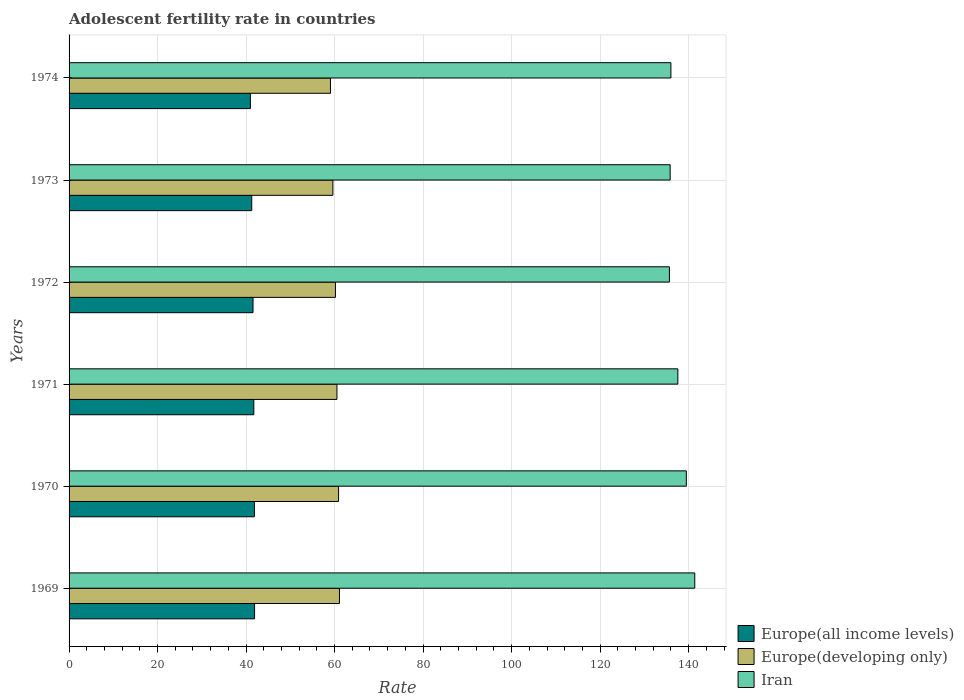Are the number of bars per tick equal to the number of legend labels?
Offer a terse response. Yes. How many bars are there on the 4th tick from the top?
Keep it short and to the point. 3. How many bars are there on the 4th tick from the bottom?
Make the answer very short. 3. What is the label of the 3rd group of bars from the top?
Your response must be concise. 1972. In how many cases, is the number of bars for a given year not equal to the number of legend labels?
Your answer should be very brief. 0. What is the adolescent fertility rate in Europe(all income levels) in 1973?
Give a very brief answer. 41.28. Across all years, what is the maximum adolescent fertility rate in Europe(developing only)?
Provide a succinct answer. 61.1. Across all years, what is the minimum adolescent fertility rate in Iran?
Your answer should be very brief. 135.66. In which year was the adolescent fertility rate in Iran maximum?
Ensure brevity in your answer.  1969. In which year was the adolescent fertility rate in Europe(developing only) minimum?
Offer a very short reply. 1974. What is the total adolescent fertility rate in Europe(all income levels) in the graph?
Ensure brevity in your answer.  249.37. What is the difference between the adolescent fertility rate in Europe(all income levels) in 1972 and that in 1973?
Your answer should be compact. 0.29. What is the difference between the adolescent fertility rate in Europe(all income levels) in 1969 and the adolescent fertility rate in Europe(developing only) in 1974?
Give a very brief answer. -17.15. What is the average adolescent fertility rate in Europe(all income levels) per year?
Your response must be concise. 41.56. In the year 1974, what is the difference between the adolescent fertility rate in Iran and adolescent fertility rate in Europe(all income levels)?
Your response must be concise. 95.03. What is the ratio of the adolescent fertility rate in Iran in 1969 to that in 1970?
Make the answer very short. 1.01. What is the difference between the highest and the second highest adolescent fertility rate in Europe(developing only)?
Keep it short and to the point. 0.2. What is the difference between the highest and the lowest adolescent fertility rate in Europe(all income levels)?
Keep it short and to the point. 0.94. What does the 2nd bar from the top in 1971 represents?
Keep it short and to the point. Europe(developing only). What does the 1st bar from the bottom in 1971 represents?
Provide a short and direct response. Europe(all income levels). Are the values on the major ticks of X-axis written in scientific E-notation?
Ensure brevity in your answer.  No. Does the graph contain grids?
Keep it short and to the point. Yes. What is the title of the graph?
Keep it short and to the point. Adolescent fertility rate in countries. Does "Kosovo" appear as one of the legend labels in the graph?
Provide a succinct answer. No. What is the label or title of the X-axis?
Provide a succinct answer. Rate. What is the Rate of Europe(all income levels) in 1969?
Your response must be concise. 41.92. What is the Rate of Europe(developing only) in 1969?
Offer a very short reply. 61.1. What is the Rate of Iran in 1969?
Offer a very short reply. 141.39. What is the Rate of Europe(all income levels) in 1970?
Make the answer very short. 41.88. What is the Rate of Europe(developing only) in 1970?
Your answer should be compact. 60.9. What is the Rate in Iran in 1970?
Provide a succinct answer. 139.48. What is the Rate in Europe(all income levels) in 1971?
Your answer should be very brief. 41.75. What is the Rate in Europe(developing only) in 1971?
Your response must be concise. 60.54. What is the Rate of Iran in 1971?
Provide a succinct answer. 137.57. What is the Rate of Europe(all income levels) in 1972?
Offer a very short reply. 41.57. What is the Rate of Europe(developing only) in 1972?
Offer a terse response. 60.2. What is the Rate of Iran in 1972?
Give a very brief answer. 135.66. What is the Rate in Europe(all income levels) in 1973?
Keep it short and to the point. 41.28. What is the Rate of Europe(developing only) in 1973?
Make the answer very short. 59.62. What is the Rate in Iran in 1973?
Give a very brief answer. 135.83. What is the Rate in Europe(all income levels) in 1974?
Your answer should be compact. 40.97. What is the Rate of Europe(developing only) in 1974?
Your answer should be very brief. 59.07. What is the Rate in Iran in 1974?
Ensure brevity in your answer.  136. Across all years, what is the maximum Rate in Europe(all income levels)?
Your response must be concise. 41.92. Across all years, what is the maximum Rate of Europe(developing only)?
Keep it short and to the point. 61.1. Across all years, what is the maximum Rate of Iran?
Provide a succinct answer. 141.39. Across all years, what is the minimum Rate in Europe(all income levels)?
Provide a succinct answer. 40.97. Across all years, what is the minimum Rate of Europe(developing only)?
Your answer should be very brief. 59.07. Across all years, what is the minimum Rate of Iran?
Provide a succinct answer. 135.66. What is the total Rate in Europe(all income levels) in the graph?
Provide a short and direct response. 249.37. What is the total Rate in Europe(developing only) in the graph?
Your response must be concise. 361.42. What is the total Rate of Iran in the graph?
Your answer should be very brief. 825.94. What is the difference between the Rate in Europe(all income levels) in 1969 and that in 1970?
Give a very brief answer. 0.04. What is the difference between the Rate in Europe(developing only) in 1969 and that in 1970?
Your response must be concise. 0.2. What is the difference between the Rate in Iran in 1969 and that in 1970?
Keep it short and to the point. 1.91. What is the difference between the Rate of Europe(all income levels) in 1969 and that in 1971?
Provide a succinct answer. 0.17. What is the difference between the Rate in Europe(developing only) in 1969 and that in 1971?
Provide a short and direct response. 0.56. What is the difference between the Rate in Iran in 1969 and that in 1971?
Keep it short and to the point. 3.82. What is the difference between the Rate of Europe(all income levels) in 1969 and that in 1972?
Provide a short and direct response. 0.35. What is the difference between the Rate of Europe(developing only) in 1969 and that in 1972?
Your answer should be compact. 0.9. What is the difference between the Rate of Iran in 1969 and that in 1972?
Provide a short and direct response. 5.73. What is the difference between the Rate in Europe(all income levels) in 1969 and that in 1973?
Offer a terse response. 0.64. What is the difference between the Rate in Europe(developing only) in 1969 and that in 1973?
Your response must be concise. 1.48. What is the difference between the Rate in Iran in 1969 and that in 1973?
Offer a terse response. 5.56. What is the difference between the Rate in Europe(all income levels) in 1969 and that in 1974?
Offer a very short reply. 0.94. What is the difference between the Rate of Europe(developing only) in 1969 and that in 1974?
Provide a succinct answer. 2.03. What is the difference between the Rate of Iran in 1969 and that in 1974?
Your response must be concise. 5.39. What is the difference between the Rate in Europe(all income levels) in 1970 and that in 1971?
Provide a succinct answer. 0.13. What is the difference between the Rate in Europe(developing only) in 1970 and that in 1971?
Your response must be concise. 0.36. What is the difference between the Rate in Iran in 1970 and that in 1971?
Offer a terse response. 1.91. What is the difference between the Rate in Europe(all income levels) in 1970 and that in 1972?
Provide a short and direct response. 0.31. What is the difference between the Rate in Europe(developing only) in 1970 and that in 1972?
Give a very brief answer. 0.7. What is the difference between the Rate of Iran in 1970 and that in 1972?
Your answer should be compact. 3.82. What is the difference between the Rate of Europe(all income levels) in 1970 and that in 1973?
Offer a terse response. 0.6. What is the difference between the Rate of Europe(developing only) in 1970 and that in 1973?
Your response must be concise. 1.28. What is the difference between the Rate of Iran in 1970 and that in 1973?
Offer a terse response. 3.65. What is the difference between the Rate in Europe(all income levels) in 1970 and that in 1974?
Give a very brief answer. 0.91. What is the difference between the Rate of Europe(developing only) in 1970 and that in 1974?
Your answer should be compact. 1.83. What is the difference between the Rate in Iran in 1970 and that in 1974?
Provide a short and direct response. 3.48. What is the difference between the Rate in Europe(all income levels) in 1971 and that in 1972?
Provide a succinct answer. 0.18. What is the difference between the Rate in Europe(developing only) in 1971 and that in 1972?
Offer a very short reply. 0.34. What is the difference between the Rate in Iran in 1971 and that in 1972?
Offer a very short reply. 1.91. What is the difference between the Rate of Europe(all income levels) in 1971 and that in 1973?
Ensure brevity in your answer.  0.47. What is the difference between the Rate in Europe(developing only) in 1971 and that in 1973?
Provide a succinct answer. 0.92. What is the difference between the Rate in Iran in 1971 and that in 1973?
Provide a short and direct response. 1.74. What is the difference between the Rate of Europe(all income levels) in 1971 and that in 1974?
Offer a very short reply. 0.78. What is the difference between the Rate in Europe(developing only) in 1971 and that in 1974?
Keep it short and to the point. 1.47. What is the difference between the Rate of Iran in 1971 and that in 1974?
Your response must be concise. 1.57. What is the difference between the Rate in Europe(all income levels) in 1972 and that in 1973?
Provide a succinct answer. 0.29. What is the difference between the Rate in Europe(developing only) in 1972 and that in 1973?
Your answer should be compact. 0.58. What is the difference between the Rate of Iran in 1972 and that in 1973?
Keep it short and to the point. -0.17. What is the difference between the Rate in Europe(all income levels) in 1972 and that in 1974?
Your answer should be very brief. 0.6. What is the difference between the Rate of Europe(developing only) in 1972 and that in 1974?
Offer a terse response. 1.13. What is the difference between the Rate of Iran in 1972 and that in 1974?
Keep it short and to the point. -0.34. What is the difference between the Rate in Europe(all income levels) in 1973 and that in 1974?
Provide a succinct answer. 0.31. What is the difference between the Rate in Europe(developing only) in 1973 and that in 1974?
Provide a succinct answer. 0.55. What is the difference between the Rate of Iran in 1973 and that in 1974?
Provide a short and direct response. -0.17. What is the difference between the Rate of Europe(all income levels) in 1969 and the Rate of Europe(developing only) in 1970?
Your answer should be compact. -18.98. What is the difference between the Rate in Europe(all income levels) in 1969 and the Rate in Iran in 1970?
Offer a terse response. -97.56. What is the difference between the Rate in Europe(developing only) in 1969 and the Rate in Iran in 1970?
Your answer should be compact. -78.38. What is the difference between the Rate in Europe(all income levels) in 1969 and the Rate in Europe(developing only) in 1971?
Provide a succinct answer. -18.62. What is the difference between the Rate of Europe(all income levels) in 1969 and the Rate of Iran in 1971?
Provide a succinct answer. -95.65. What is the difference between the Rate in Europe(developing only) in 1969 and the Rate in Iran in 1971?
Offer a terse response. -76.47. What is the difference between the Rate of Europe(all income levels) in 1969 and the Rate of Europe(developing only) in 1972?
Give a very brief answer. -18.28. What is the difference between the Rate of Europe(all income levels) in 1969 and the Rate of Iran in 1972?
Offer a very short reply. -93.74. What is the difference between the Rate in Europe(developing only) in 1969 and the Rate in Iran in 1972?
Offer a very short reply. -74.56. What is the difference between the Rate in Europe(all income levels) in 1969 and the Rate in Europe(developing only) in 1973?
Your response must be concise. -17.7. What is the difference between the Rate of Europe(all income levels) in 1969 and the Rate of Iran in 1973?
Your answer should be very brief. -93.91. What is the difference between the Rate in Europe(developing only) in 1969 and the Rate in Iran in 1973?
Offer a terse response. -74.73. What is the difference between the Rate of Europe(all income levels) in 1969 and the Rate of Europe(developing only) in 1974?
Give a very brief answer. -17.15. What is the difference between the Rate of Europe(all income levels) in 1969 and the Rate of Iran in 1974?
Your answer should be very brief. -94.08. What is the difference between the Rate in Europe(developing only) in 1969 and the Rate in Iran in 1974?
Provide a succinct answer. -74.9. What is the difference between the Rate of Europe(all income levels) in 1970 and the Rate of Europe(developing only) in 1971?
Offer a very short reply. -18.66. What is the difference between the Rate in Europe(all income levels) in 1970 and the Rate in Iran in 1971?
Keep it short and to the point. -95.69. What is the difference between the Rate of Europe(developing only) in 1970 and the Rate of Iran in 1971?
Your answer should be compact. -76.67. What is the difference between the Rate of Europe(all income levels) in 1970 and the Rate of Europe(developing only) in 1972?
Give a very brief answer. -18.31. What is the difference between the Rate of Europe(all income levels) in 1970 and the Rate of Iran in 1972?
Provide a succinct answer. -93.78. What is the difference between the Rate in Europe(developing only) in 1970 and the Rate in Iran in 1972?
Your response must be concise. -74.76. What is the difference between the Rate of Europe(all income levels) in 1970 and the Rate of Europe(developing only) in 1973?
Give a very brief answer. -17.74. What is the difference between the Rate in Europe(all income levels) in 1970 and the Rate in Iran in 1973?
Keep it short and to the point. -93.95. What is the difference between the Rate in Europe(developing only) in 1970 and the Rate in Iran in 1973?
Offer a terse response. -74.93. What is the difference between the Rate of Europe(all income levels) in 1970 and the Rate of Europe(developing only) in 1974?
Give a very brief answer. -17.19. What is the difference between the Rate of Europe(all income levels) in 1970 and the Rate of Iran in 1974?
Give a very brief answer. -94.12. What is the difference between the Rate in Europe(developing only) in 1970 and the Rate in Iran in 1974?
Your answer should be compact. -75.1. What is the difference between the Rate of Europe(all income levels) in 1971 and the Rate of Europe(developing only) in 1972?
Provide a short and direct response. -18.45. What is the difference between the Rate in Europe(all income levels) in 1971 and the Rate in Iran in 1972?
Offer a terse response. -93.91. What is the difference between the Rate of Europe(developing only) in 1971 and the Rate of Iran in 1972?
Provide a short and direct response. -75.12. What is the difference between the Rate in Europe(all income levels) in 1971 and the Rate in Europe(developing only) in 1973?
Offer a very short reply. -17.87. What is the difference between the Rate in Europe(all income levels) in 1971 and the Rate in Iran in 1973?
Make the answer very short. -94.08. What is the difference between the Rate of Europe(developing only) in 1971 and the Rate of Iran in 1973?
Make the answer very short. -75.29. What is the difference between the Rate of Europe(all income levels) in 1971 and the Rate of Europe(developing only) in 1974?
Your answer should be compact. -17.32. What is the difference between the Rate in Europe(all income levels) in 1971 and the Rate in Iran in 1974?
Ensure brevity in your answer.  -94.25. What is the difference between the Rate in Europe(developing only) in 1971 and the Rate in Iran in 1974?
Your response must be concise. -75.46. What is the difference between the Rate of Europe(all income levels) in 1972 and the Rate of Europe(developing only) in 1973?
Ensure brevity in your answer.  -18.05. What is the difference between the Rate in Europe(all income levels) in 1972 and the Rate in Iran in 1973?
Your answer should be compact. -94.26. What is the difference between the Rate in Europe(developing only) in 1972 and the Rate in Iran in 1973?
Provide a short and direct response. -75.63. What is the difference between the Rate of Europe(all income levels) in 1972 and the Rate of Europe(developing only) in 1974?
Make the answer very short. -17.5. What is the difference between the Rate in Europe(all income levels) in 1972 and the Rate in Iran in 1974?
Your answer should be very brief. -94.43. What is the difference between the Rate in Europe(developing only) in 1972 and the Rate in Iran in 1974?
Ensure brevity in your answer.  -75.81. What is the difference between the Rate in Europe(all income levels) in 1973 and the Rate in Europe(developing only) in 1974?
Make the answer very short. -17.79. What is the difference between the Rate of Europe(all income levels) in 1973 and the Rate of Iran in 1974?
Provide a succinct answer. -94.72. What is the difference between the Rate of Europe(developing only) in 1973 and the Rate of Iran in 1974?
Offer a terse response. -76.38. What is the average Rate in Europe(all income levels) per year?
Keep it short and to the point. 41.56. What is the average Rate in Europe(developing only) per year?
Your answer should be compact. 60.24. What is the average Rate in Iran per year?
Keep it short and to the point. 137.66. In the year 1969, what is the difference between the Rate in Europe(all income levels) and Rate in Europe(developing only)?
Offer a terse response. -19.18. In the year 1969, what is the difference between the Rate in Europe(all income levels) and Rate in Iran?
Offer a terse response. -99.48. In the year 1969, what is the difference between the Rate of Europe(developing only) and Rate of Iran?
Make the answer very short. -80.29. In the year 1970, what is the difference between the Rate in Europe(all income levels) and Rate in Europe(developing only)?
Give a very brief answer. -19.02. In the year 1970, what is the difference between the Rate in Europe(all income levels) and Rate in Iran?
Your answer should be very brief. -97.6. In the year 1970, what is the difference between the Rate of Europe(developing only) and Rate of Iran?
Your answer should be compact. -78.58. In the year 1971, what is the difference between the Rate in Europe(all income levels) and Rate in Europe(developing only)?
Provide a succinct answer. -18.79. In the year 1971, what is the difference between the Rate in Europe(all income levels) and Rate in Iran?
Your response must be concise. -95.82. In the year 1971, what is the difference between the Rate in Europe(developing only) and Rate in Iran?
Keep it short and to the point. -77.03. In the year 1972, what is the difference between the Rate of Europe(all income levels) and Rate of Europe(developing only)?
Provide a short and direct response. -18.63. In the year 1972, what is the difference between the Rate in Europe(all income levels) and Rate in Iran?
Your answer should be compact. -94.09. In the year 1972, what is the difference between the Rate in Europe(developing only) and Rate in Iran?
Give a very brief answer. -75.46. In the year 1973, what is the difference between the Rate in Europe(all income levels) and Rate in Europe(developing only)?
Offer a very short reply. -18.34. In the year 1973, what is the difference between the Rate in Europe(all income levels) and Rate in Iran?
Offer a terse response. -94.55. In the year 1973, what is the difference between the Rate in Europe(developing only) and Rate in Iran?
Ensure brevity in your answer.  -76.21. In the year 1974, what is the difference between the Rate of Europe(all income levels) and Rate of Europe(developing only)?
Provide a succinct answer. -18.09. In the year 1974, what is the difference between the Rate of Europe(all income levels) and Rate of Iran?
Offer a very short reply. -95.03. In the year 1974, what is the difference between the Rate of Europe(developing only) and Rate of Iran?
Offer a terse response. -76.93. What is the ratio of the Rate of Europe(developing only) in 1969 to that in 1970?
Your answer should be very brief. 1. What is the ratio of the Rate of Iran in 1969 to that in 1970?
Ensure brevity in your answer.  1.01. What is the ratio of the Rate in Europe(developing only) in 1969 to that in 1971?
Provide a short and direct response. 1.01. What is the ratio of the Rate in Iran in 1969 to that in 1971?
Your answer should be compact. 1.03. What is the ratio of the Rate of Europe(all income levels) in 1969 to that in 1972?
Give a very brief answer. 1.01. What is the ratio of the Rate of Europe(developing only) in 1969 to that in 1972?
Your answer should be very brief. 1.01. What is the ratio of the Rate in Iran in 1969 to that in 1972?
Offer a very short reply. 1.04. What is the ratio of the Rate of Europe(all income levels) in 1969 to that in 1973?
Make the answer very short. 1.02. What is the ratio of the Rate of Europe(developing only) in 1969 to that in 1973?
Provide a short and direct response. 1.02. What is the ratio of the Rate in Iran in 1969 to that in 1973?
Your answer should be compact. 1.04. What is the ratio of the Rate in Europe(all income levels) in 1969 to that in 1974?
Provide a succinct answer. 1.02. What is the ratio of the Rate in Europe(developing only) in 1969 to that in 1974?
Offer a very short reply. 1.03. What is the ratio of the Rate of Iran in 1969 to that in 1974?
Keep it short and to the point. 1.04. What is the ratio of the Rate of Europe(all income levels) in 1970 to that in 1971?
Provide a succinct answer. 1. What is the ratio of the Rate in Europe(developing only) in 1970 to that in 1971?
Your response must be concise. 1.01. What is the ratio of the Rate of Iran in 1970 to that in 1971?
Provide a succinct answer. 1.01. What is the ratio of the Rate of Europe(all income levels) in 1970 to that in 1972?
Provide a short and direct response. 1.01. What is the ratio of the Rate in Europe(developing only) in 1970 to that in 1972?
Provide a succinct answer. 1.01. What is the ratio of the Rate in Iran in 1970 to that in 1972?
Keep it short and to the point. 1.03. What is the ratio of the Rate of Europe(all income levels) in 1970 to that in 1973?
Give a very brief answer. 1.01. What is the ratio of the Rate in Europe(developing only) in 1970 to that in 1973?
Offer a terse response. 1.02. What is the ratio of the Rate in Iran in 1970 to that in 1973?
Provide a succinct answer. 1.03. What is the ratio of the Rate in Europe(all income levels) in 1970 to that in 1974?
Your answer should be compact. 1.02. What is the ratio of the Rate of Europe(developing only) in 1970 to that in 1974?
Provide a short and direct response. 1.03. What is the ratio of the Rate in Iran in 1970 to that in 1974?
Give a very brief answer. 1.03. What is the ratio of the Rate of Europe(developing only) in 1971 to that in 1972?
Your answer should be compact. 1.01. What is the ratio of the Rate in Iran in 1971 to that in 1972?
Keep it short and to the point. 1.01. What is the ratio of the Rate in Europe(all income levels) in 1971 to that in 1973?
Offer a very short reply. 1.01. What is the ratio of the Rate in Europe(developing only) in 1971 to that in 1973?
Your answer should be very brief. 1.02. What is the ratio of the Rate in Iran in 1971 to that in 1973?
Give a very brief answer. 1.01. What is the ratio of the Rate in Europe(all income levels) in 1971 to that in 1974?
Your answer should be compact. 1.02. What is the ratio of the Rate in Europe(developing only) in 1971 to that in 1974?
Your answer should be compact. 1.02. What is the ratio of the Rate in Iran in 1971 to that in 1974?
Your answer should be compact. 1.01. What is the ratio of the Rate of Europe(all income levels) in 1972 to that in 1973?
Keep it short and to the point. 1.01. What is the ratio of the Rate in Europe(developing only) in 1972 to that in 1973?
Offer a terse response. 1.01. What is the ratio of the Rate of Iran in 1972 to that in 1973?
Provide a short and direct response. 1. What is the ratio of the Rate in Europe(all income levels) in 1972 to that in 1974?
Keep it short and to the point. 1.01. What is the ratio of the Rate of Europe(developing only) in 1972 to that in 1974?
Your answer should be very brief. 1.02. What is the ratio of the Rate of Europe(all income levels) in 1973 to that in 1974?
Ensure brevity in your answer.  1.01. What is the ratio of the Rate of Europe(developing only) in 1973 to that in 1974?
Make the answer very short. 1.01. What is the ratio of the Rate of Iran in 1973 to that in 1974?
Ensure brevity in your answer.  1. What is the difference between the highest and the second highest Rate in Europe(all income levels)?
Keep it short and to the point. 0.04. What is the difference between the highest and the second highest Rate of Europe(developing only)?
Ensure brevity in your answer.  0.2. What is the difference between the highest and the second highest Rate in Iran?
Offer a very short reply. 1.91. What is the difference between the highest and the lowest Rate in Europe(all income levels)?
Give a very brief answer. 0.94. What is the difference between the highest and the lowest Rate of Europe(developing only)?
Provide a short and direct response. 2.03. What is the difference between the highest and the lowest Rate of Iran?
Make the answer very short. 5.73. 